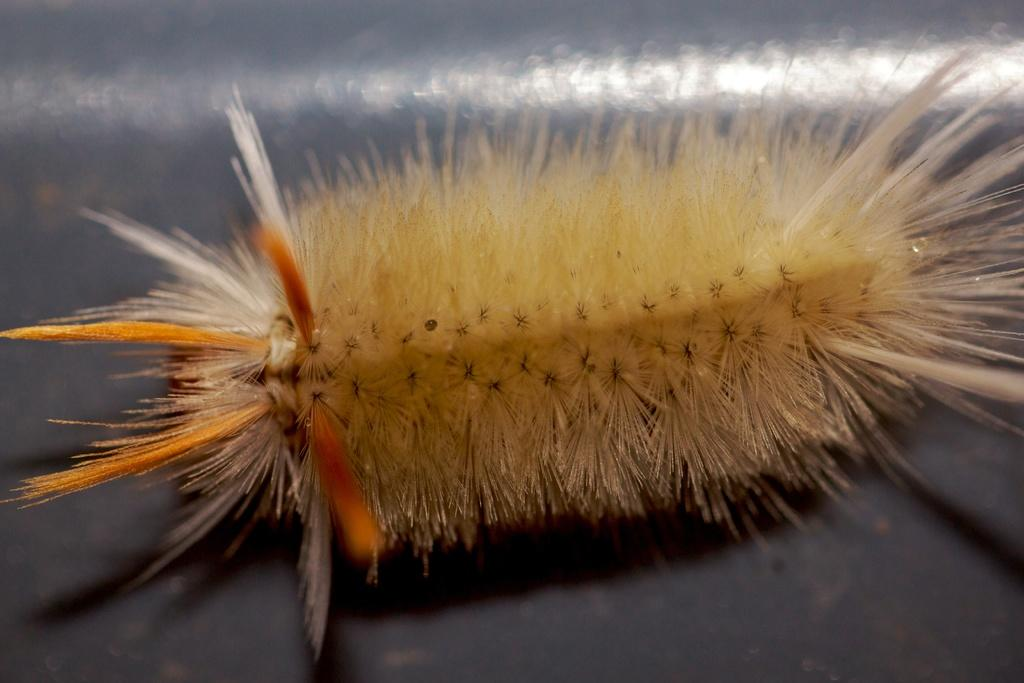What type of invention is being demonstrated in the image? There is no invention present in the image, as no specific facts were provided. What material is the steel structure made of in the image? There is no steel structure present in the image, as no specific facts were provided. What type of underwear is being worn by the person in the image? There is no person present in the image, as no specific facts were provided. 